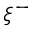<formula> <loc_0><loc_0><loc_500><loc_500>\xi ^ { - }</formula> 